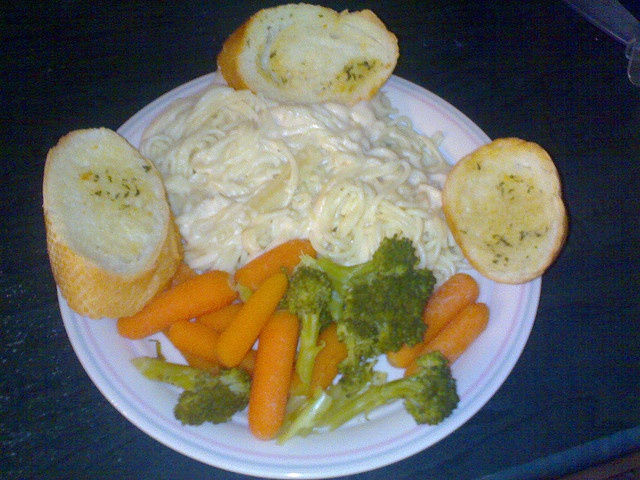Describe the objects in this image and their specific colors. I can see dining table in black, darkgray, navy, tan, and lavender tones, broccoli in black and olive tones, carrot in black, orange, and olive tones, carrot in black, olive, salmon, and tan tones, and broccoli in black, olive, and gray tones in this image. 